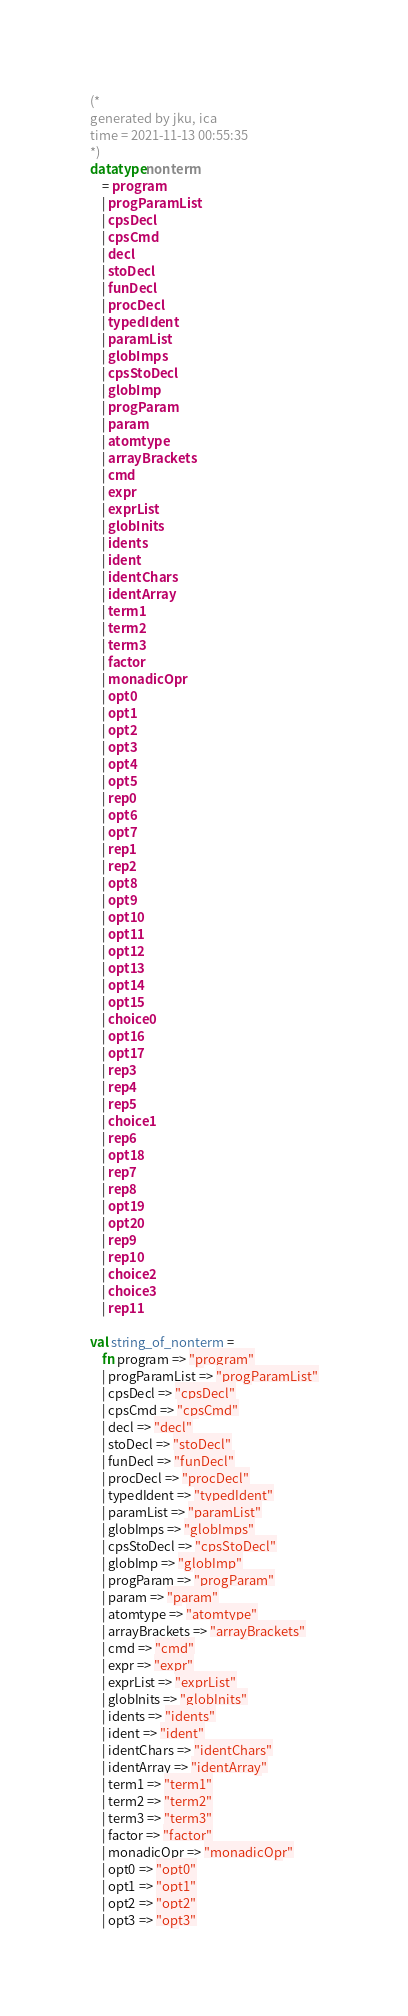<code> <loc_0><loc_0><loc_500><loc_500><_SML_>
(*
generated by jku, ica
time = 2021-11-13 00:55:35
*)
datatype nonterm
    = program
    | progParamList
    | cpsDecl
    | cpsCmd
    | decl
    | stoDecl
    | funDecl
    | procDecl
    | typedIdent
    | paramList
    | globImps
    | cpsStoDecl
    | globImp
    | progParam
    | param
    | atomtype
    | arrayBrackets
    | cmd
    | expr
    | exprList
    | globInits
    | idents
    | ident
    | identChars
    | identArray
    | term1
    | term2
    | term3
    | factor
    | monadicOpr
    | opt0
    | opt1
    | opt2
    | opt3
    | opt4
    | opt5
    | rep0
    | opt6
    | opt7
    | rep1
    | rep2
    | opt8
    | opt9
    | opt10
    | opt11
    | opt12
    | opt13
    | opt14
    | opt15
    | choice0
    | opt16
    | opt17
    | rep3
    | rep4
    | rep5
    | choice1
    | rep6
    | opt18
    | rep7
    | rep8
    | opt19
    | opt20
    | rep9
    | rep10
    | choice2
    | choice3
    | rep11

val string_of_nonterm =
    fn program => "program"
    | progParamList => "progParamList"
    | cpsDecl => "cpsDecl"
    | cpsCmd => "cpsCmd"
    | decl => "decl"
    | stoDecl => "stoDecl"
    | funDecl => "funDecl"
    | procDecl => "procDecl"
    | typedIdent => "typedIdent"
    | paramList => "paramList"
    | globImps => "globImps"
    | cpsStoDecl => "cpsStoDecl"
    | globImp => "globImp"
    | progParam => "progParam"
    | param => "param"
    | atomtype => "atomtype"
    | arrayBrackets => "arrayBrackets"
    | cmd => "cmd"
    | expr => "expr"
    | exprList => "exprList"
    | globInits => "globInits"
    | idents => "idents"
    | ident => "ident"
    | identChars => "identChars"
    | identArray => "identArray"
    | term1 => "term1"
    | term2 => "term2"
    | term3 => "term3"
    | factor => "factor"
    | monadicOpr => "monadicOpr"
    | opt0 => "opt0"
    | opt1 => "opt1"
    | opt2 => "opt2"
    | opt3 => "opt3"</code> 